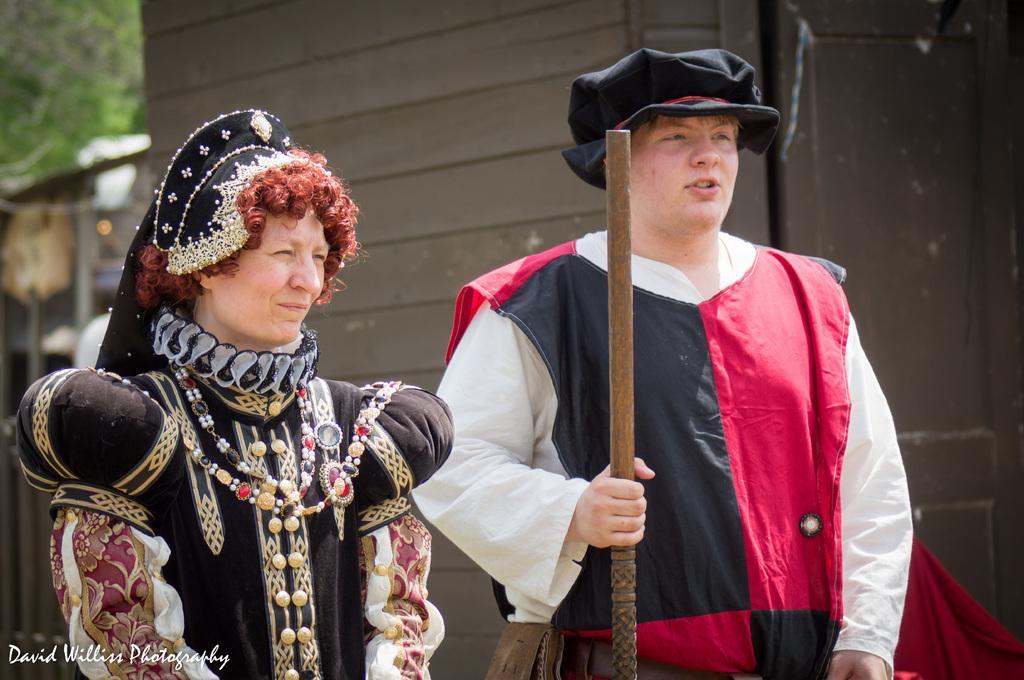Please provide a concise description of this image. In this image we can see a man and a woman standing wearing the costume. In that a man is holding a wooden stick. On the backside we can see a cloth, wall and a door. 